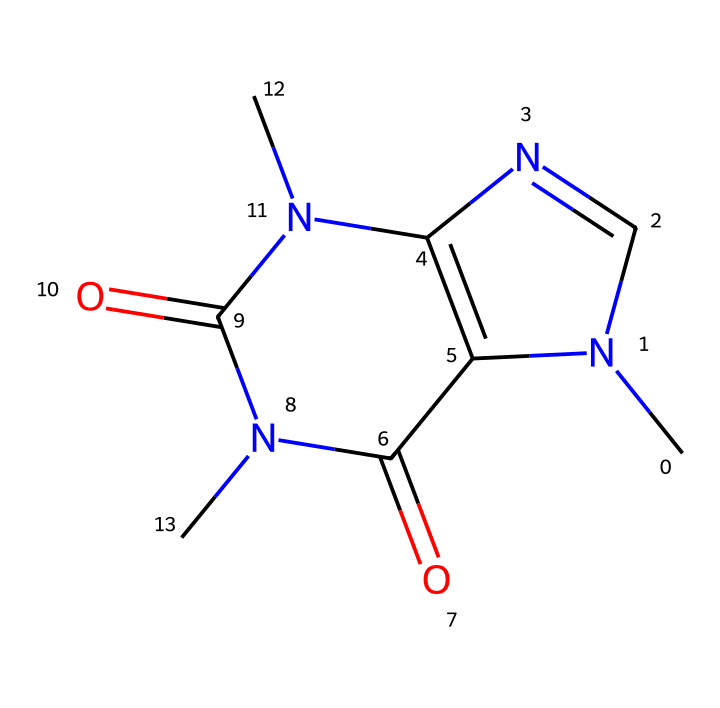what is the molecular formula of caffeine? To find the molecular formula, count the number of each type of atom in the SMILES. The SMILES indicates there are 8 carbon (C), 10 hydrogen (H), 4 nitrogen (N), and 2 oxygen (O) atoms. Therefore, the molecular formula is C8H10N4O2.
Answer: C8H10N4O2 how many nitrogen atoms are present in caffeine? By looking at the SMILES representation, we can identify all the nitrogen (N) atoms present. There are four nitrogen atoms in the structural representation.
Answer: 4 does caffeine contain any double bonds? The SMILES notation indicates the presence of double bonds, particularly in the cyclic structure with nitrogen atoms. The 'C=' and 'N=' indicate double bonds, confirming that caffeine does contain double bonds.
Answer: yes what type of compound is caffeine classified as? Given the presence of nitrogen atoms and the functional groups indicated in the structure, caffeine can be classified as an alkaloid, which is a class of nitrogen-containing organic compounds.
Answer: alkaloid how many rings are present in caffeine's structure? Analyzing the SMILES structure, we can see that caffeine comprises two interconnected rings, shown by the use of numbers (1 and 2) to denote ring closures in the sequence.
Answer: 2 is caffeine an aliphatic or aromatic compound? Caffeine has a structure featuring rings with alternating double bonds, indicative of aromatic characteristics, even though it contains aliphatic chains. However, it is primarily classified as an alkaloid, rather than purely aliphatic.
Answer: aromatic 